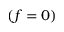Convert formula to latex. <formula><loc_0><loc_0><loc_500><loc_500>( f = 0 )</formula> 